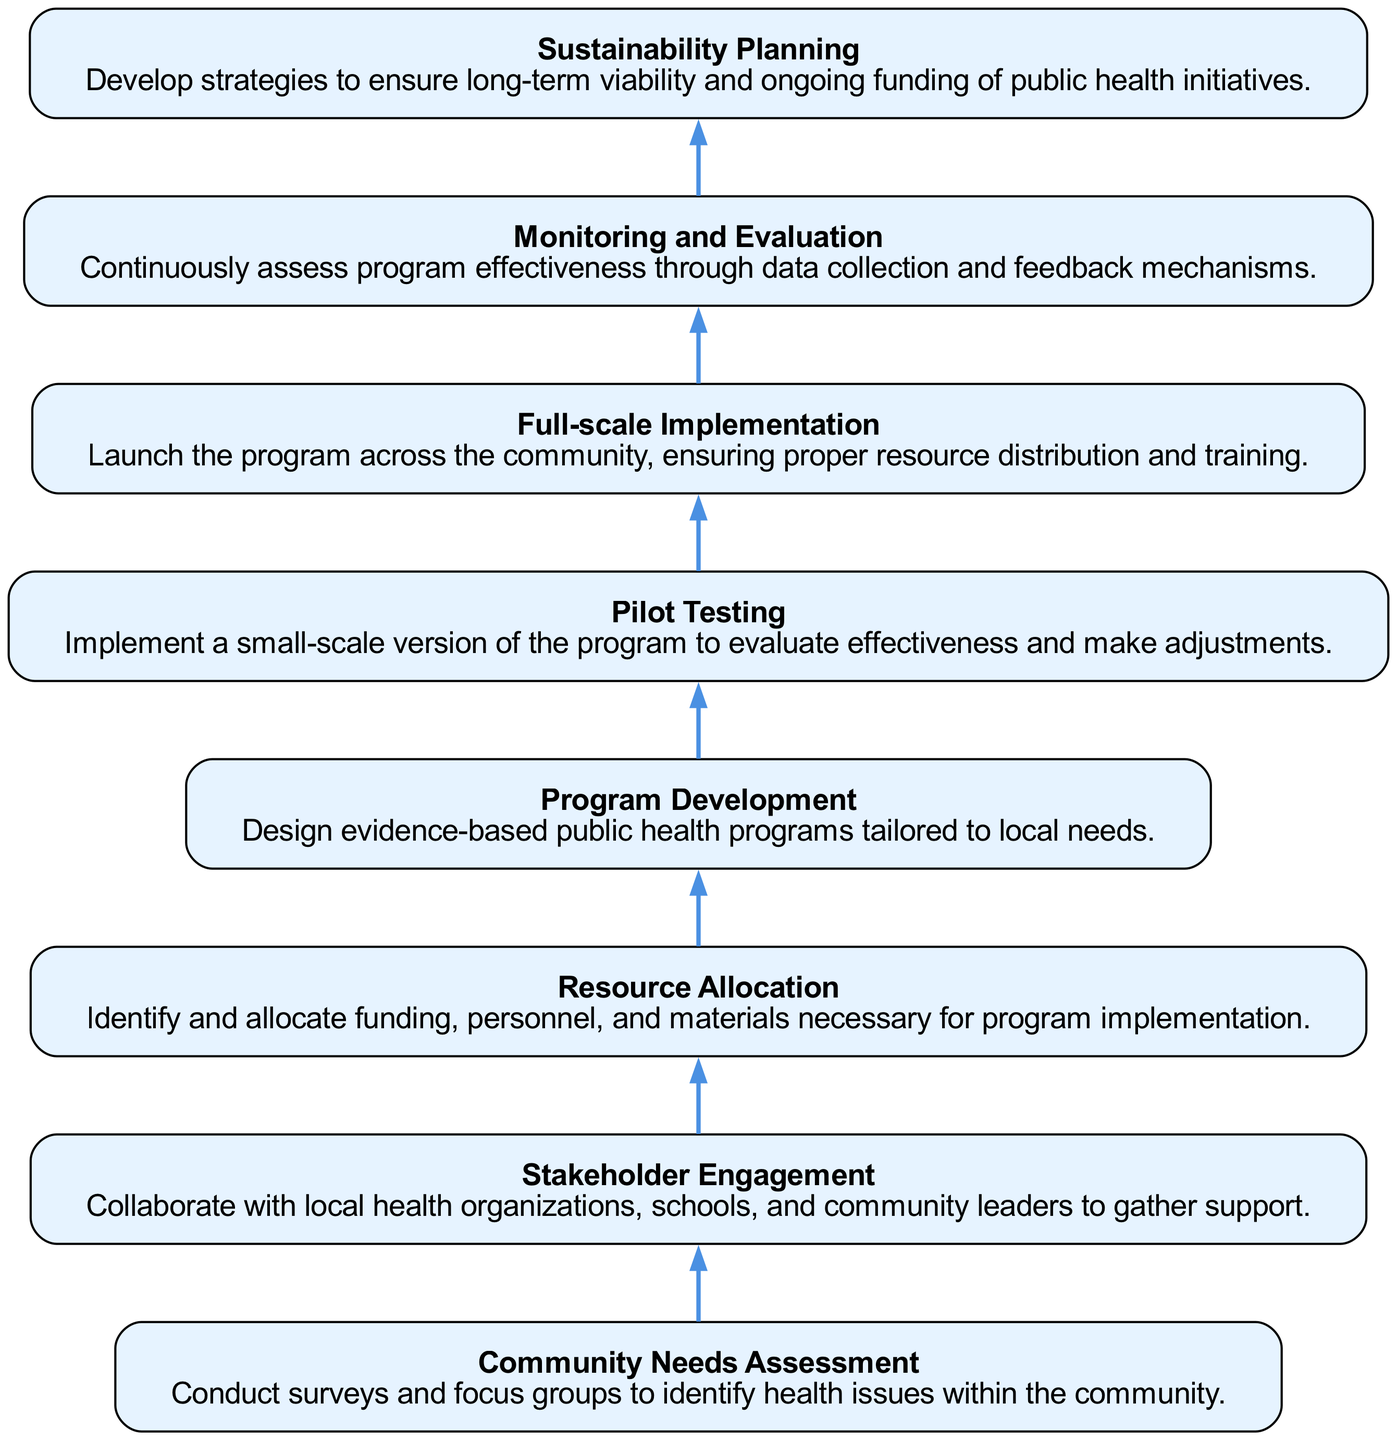What is the first step in the diagram? The first step in the diagram is "Community Needs Assessment," which starts the flow of the public health initiative.
Answer: Community Needs Assessment How many total steps are there? By counting the listed steps in the diagram, there are a total of eight steps outlined for the public health initiative implementation.
Answer: 8 What is the last step in the diagram? The last step in the diagram is "Sustainability Planning," which ensures the long-term viability of the health initiatives.
Answer: Sustainability Planning Which step follows "Program Development"? After "Program Development," the next step in the flow is "Pilot Testing," which evaluates the program's effectiveness in a small-scale.
Answer: Pilot Testing Which two steps directly precede "Full-scale Implementation"? The two steps that come before "Full-scale Implementation" are "Pilot Testing" and "Program Development," indicating the program must be developed and tested before being fully implemented.
Answer: Pilot Testing, Program Development What is the relationship between "Monitoring and Evaluation" and "Sustainability Planning"? "Monitoring and Evaluation" comes directly before "Sustainability Planning" in the diagram, suggesting that ongoing assessment contributes to planning for long-term sustainability.
Answer: Monitoring and Evaluation Which step involves collaboration with local organizations? The step that specifically involves collaboration with local organizations is "Stakeholder Engagement," aimed at garnering support for the health initiatives.
Answer: Stakeholder Engagement What type of programs are designed in "Program Development"? In "Program Development," the programs designed are "evidence-based public health programs," tailored specifically to meet the local community needs.
Answer: evidence-based public health programs What is the purpose of "Pilot Testing"? The purpose of "Pilot Testing" is to implement a small-scale version of the health program to evaluate effectiveness before broader implementation.
Answer: evaluate effectiveness 